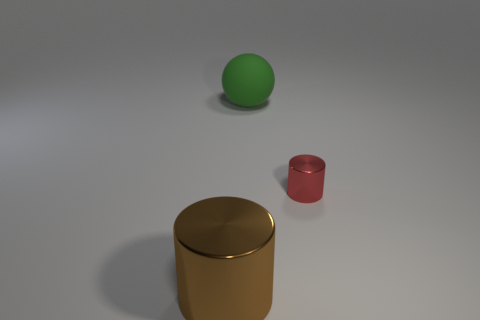How would you describe the aesthetic of this image? The image has a minimalist aesthetic, with clean lines and a limited color palette. The composition is straightforward and balanced, using basic geometric shapes that evoke a modern and perhaps educational feel. The neutral background accentuates the simplicity and allows viewers to focus on the form and material of each object. 